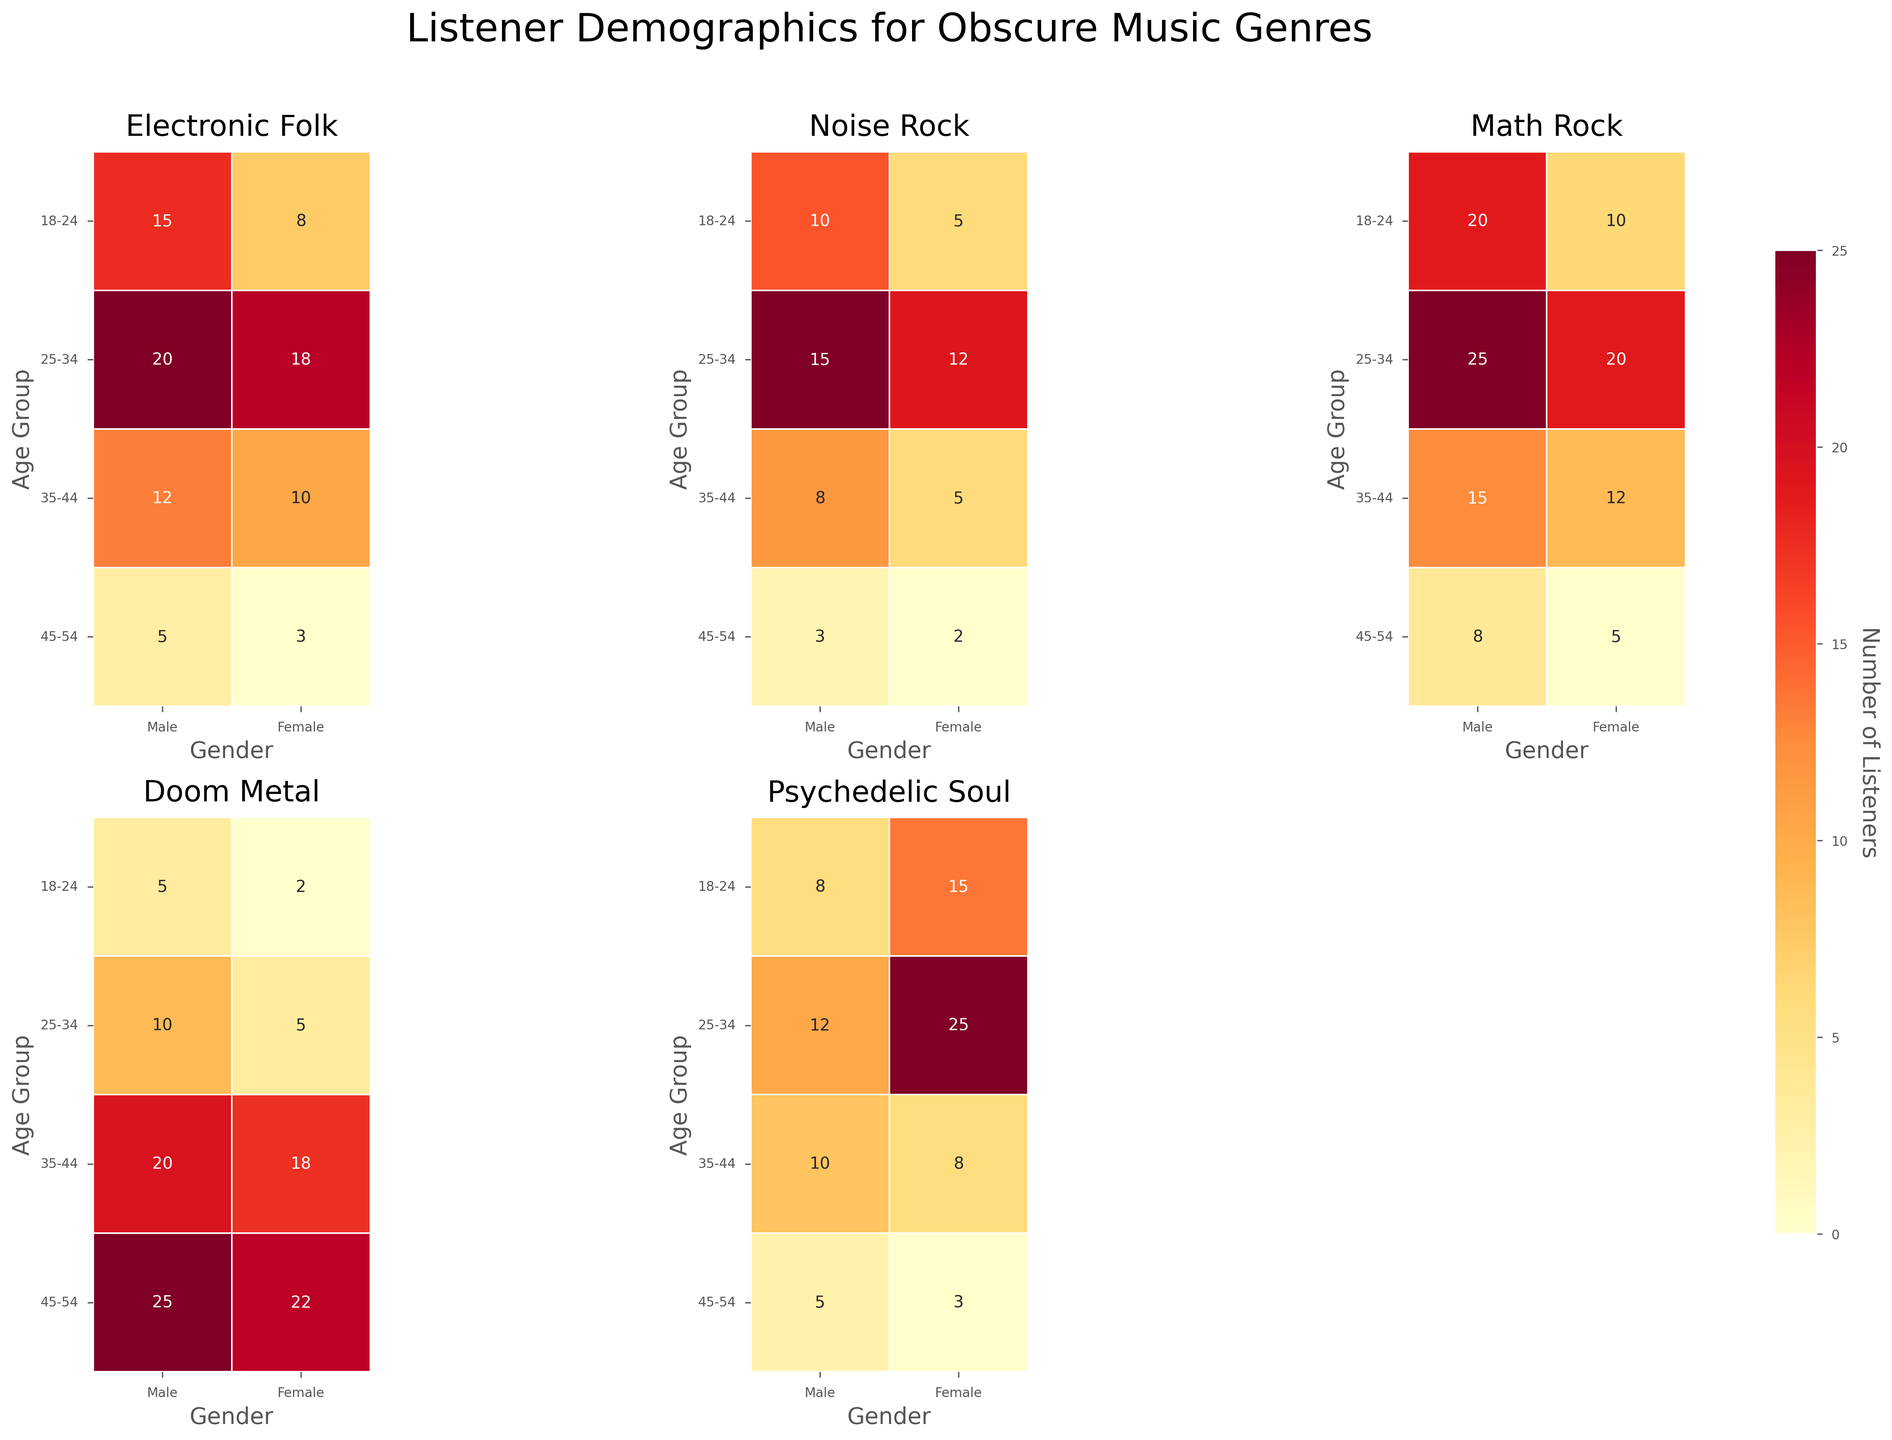What is the title of the figure? The title is located at the top of the figure and provides an overview of the data being visualized. It helps readers quickly understand the context.
Answer: Listener Demographics for Obscure Music Genres Which age group and gender combination has the highest number of listeners for Psychedelic Soul? To find the answer, look for the highest value in the heatmap specific to Psychedelic Soul. Compare the values across both age groups and genders.
Answer: 25-34, Female Which genre has the least number of listeners in the 18-24 age group for Females? Check the heatmap for the 18-24 age group for Females and identify the genre with the smallest value. Compare all the values in this subset.
Answer: Doom Metal What is the total number of male listeners aged 35-44 across all genres? Sum the values from each genre's heatmap where the age group is 35-44 and gender is Male. The calculation involves adding the listener counts for Electronic Folk, Noise Rock, Math Rock, Doom Metal, and Psychedelic Soul.
Answer: 65 What is the average number of female listeners aged 45-54 across all genres? First, sum the number of listeners for each genre for the 45-54 age group and Female gender. Then, divide the sum by the number of genres (5).
Answer: 7 Which genre shows the greatest difference in the number of listeners between males and females aged 25-34? For each genre, calculate the absolute difference between the number of Male and Female listeners within the 25-34 age group. Compare these differences to find the greatest one.
Answer: Psychedelic Soul Which genre has a more balanced listener distribution between ages 25-34 and 35-44 for males? For each genre, compare the number of listeners for Males aged 25-34 and Males aged 35-44. The genre with the smallest difference between these two age groups has the most balanced distribution.
Answer: Psychedelic Soul Which gender listens more to Noise Rock in the 18-24 age group? Look at the values for both Males and Females in the 18-24 age group within the Noise Rock heatmap. Compare the numbers to determine which gender has a higher count.
Answer: Male What age group has the highest number of listeners for Doom Metal? Compare the values across all age groups for Doom Metal. Identify the age group with the highest value.
Answer: 45-54 How does the number of female listeners of Math Rock aged 25-34 compare to male listeners of Noise Rock aged 35-44? First, identify the number of Female listeners of Math Rock aged 25-34 and Male listeners of Noise Rock aged 35-44. Compare these two values to see which is higher.
Answer: Math Rock (Female 25-34: 20) vs Noise Rock (Male 35-44: 8) - Math Rock has more 